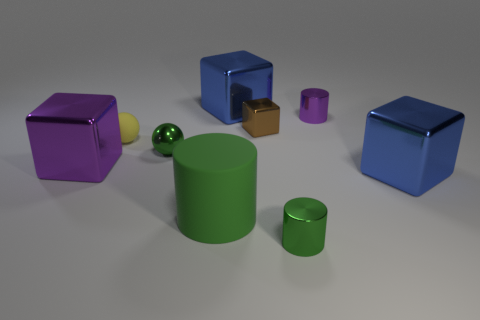Do the green matte thing and the small object that is in front of the purple block have the same shape?
Your response must be concise. Yes. What is the material of the big cylinder that is the same color as the metal ball?
Offer a very short reply. Rubber. There is a matte object behind the matte cylinder; what size is it?
Provide a short and direct response. Small. Are there any tiny things of the same color as the tiny shiny sphere?
Give a very brief answer. Yes. There is a blue metallic cube that is in front of the yellow thing; is its size the same as the tiny brown block?
Provide a short and direct response. No. The shiny ball is what color?
Make the answer very short. Green. There is a cylinder left of the blue cube that is behind the tiny purple thing; what color is it?
Keep it short and to the point. Green. Is there a gray block that has the same material as the tiny brown thing?
Provide a succinct answer. No. The yellow object behind the large green rubber cylinder that is left of the small purple metallic cylinder is made of what material?
Your answer should be compact. Rubber. How many tiny green shiny things are the same shape as the large green rubber thing?
Give a very brief answer. 1. 